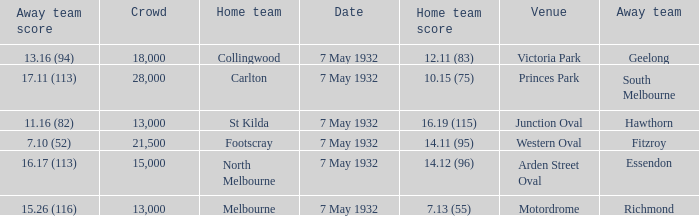What is the largest crowd with Away team score of 13.16 (94)? 18000.0. 